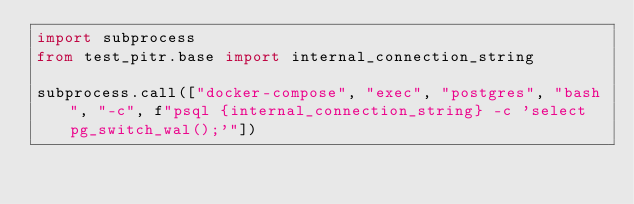Convert code to text. <code><loc_0><loc_0><loc_500><loc_500><_Python_>import subprocess
from test_pitr.base import internal_connection_string

subprocess.call(["docker-compose", "exec", "postgres", "bash", "-c", f"psql {internal_connection_string} -c 'select pg_switch_wal();'"])</code> 